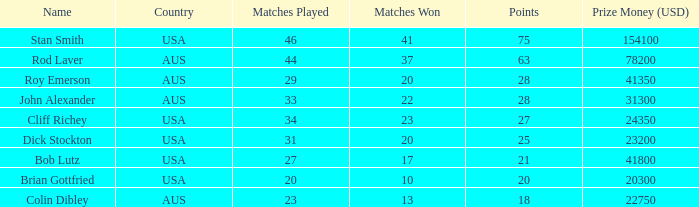How many games did the player who participated in 23 matches win? 13.0. 